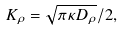<formula> <loc_0><loc_0><loc_500><loc_500>K _ { \rho } = \sqrt { \pi \kappa D _ { \rho } } / 2 ,</formula> 